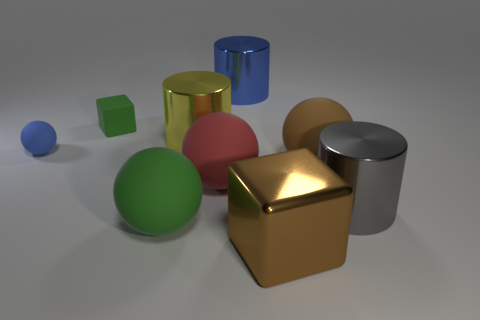Subtract all cylinders. How many objects are left? 6 Add 3 large brown spheres. How many large brown spheres are left? 4 Add 7 large red rubber balls. How many large red rubber balls exist? 8 Subtract 0 cyan spheres. How many objects are left? 9 Subtract all large brown blocks. Subtract all tiny blue matte objects. How many objects are left? 7 